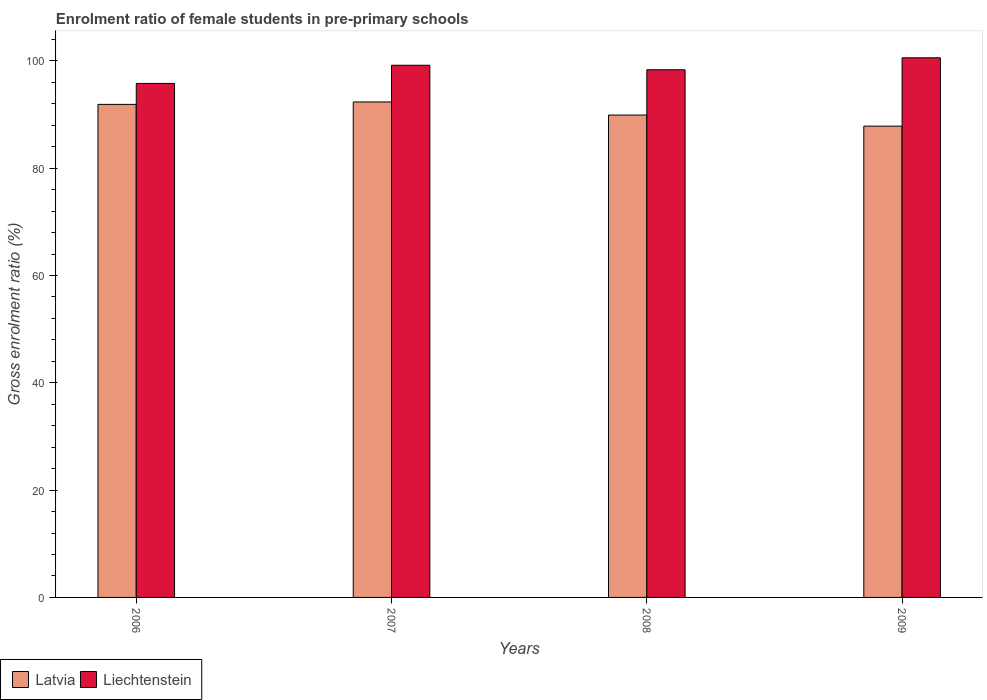How many groups of bars are there?
Ensure brevity in your answer.  4. How many bars are there on the 4th tick from the left?
Offer a terse response. 2. What is the enrolment ratio of female students in pre-primary schools in Latvia in 2008?
Give a very brief answer. 89.9. Across all years, what is the maximum enrolment ratio of female students in pre-primary schools in Liechtenstein?
Your response must be concise. 100.57. Across all years, what is the minimum enrolment ratio of female students in pre-primary schools in Latvia?
Keep it short and to the point. 87.83. In which year was the enrolment ratio of female students in pre-primary schools in Liechtenstein maximum?
Give a very brief answer. 2009. In which year was the enrolment ratio of female students in pre-primary schools in Liechtenstein minimum?
Offer a very short reply. 2006. What is the total enrolment ratio of female students in pre-primary schools in Latvia in the graph?
Your response must be concise. 361.96. What is the difference between the enrolment ratio of female students in pre-primary schools in Liechtenstein in 2007 and that in 2009?
Provide a succinct answer. -1.39. What is the difference between the enrolment ratio of female students in pre-primary schools in Latvia in 2008 and the enrolment ratio of female students in pre-primary schools in Liechtenstein in 2007?
Offer a terse response. -9.28. What is the average enrolment ratio of female students in pre-primary schools in Liechtenstein per year?
Ensure brevity in your answer.  98.47. In the year 2009, what is the difference between the enrolment ratio of female students in pre-primary schools in Latvia and enrolment ratio of female students in pre-primary schools in Liechtenstein?
Make the answer very short. -12.74. What is the ratio of the enrolment ratio of female students in pre-primary schools in Latvia in 2006 to that in 2008?
Your answer should be compact. 1.02. What is the difference between the highest and the second highest enrolment ratio of female students in pre-primary schools in Liechtenstein?
Provide a succinct answer. 1.39. What is the difference between the highest and the lowest enrolment ratio of female students in pre-primary schools in Liechtenstein?
Your response must be concise. 4.78. What does the 2nd bar from the left in 2009 represents?
Provide a succinct answer. Liechtenstein. What does the 1st bar from the right in 2009 represents?
Ensure brevity in your answer.  Liechtenstein. How many years are there in the graph?
Ensure brevity in your answer.  4. What is the difference between two consecutive major ticks on the Y-axis?
Provide a short and direct response. 20. Does the graph contain any zero values?
Keep it short and to the point. No. Does the graph contain grids?
Offer a very short reply. No. How many legend labels are there?
Keep it short and to the point. 2. What is the title of the graph?
Make the answer very short. Enrolment ratio of female students in pre-primary schools. Does "Macedonia" appear as one of the legend labels in the graph?
Provide a short and direct response. No. What is the label or title of the Y-axis?
Ensure brevity in your answer.  Gross enrolment ratio (%). What is the Gross enrolment ratio (%) in Latvia in 2006?
Provide a short and direct response. 91.89. What is the Gross enrolment ratio (%) of Liechtenstein in 2006?
Provide a short and direct response. 95.79. What is the Gross enrolment ratio (%) of Latvia in 2007?
Your answer should be very brief. 92.34. What is the Gross enrolment ratio (%) in Liechtenstein in 2007?
Offer a very short reply. 99.18. What is the Gross enrolment ratio (%) of Latvia in 2008?
Offer a terse response. 89.9. What is the Gross enrolment ratio (%) in Liechtenstein in 2008?
Give a very brief answer. 98.34. What is the Gross enrolment ratio (%) of Latvia in 2009?
Give a very brief answer. 87.83. What is the Gross enrolment ratio (%) in Liechtenstein in 2009?
Make the answer very short. 100.57. Across all years, what is the maximum Gross enrolment ratio (%) in Latvia?
Provide a succinct answer. 92.34. Across all years, what is the maximum Gross enrolment ratio (%) in Liechtenstein?
Give a very brief answer. 100.57. Across all years, what is the minimum Gross enrolment ratio (%) in Latvia?
Your answer should be very brief. 87.83. Across all years, what is the minimum Gross enrolment ratio (%) in Liechtenstein?
Offer a terse response. 95.79. What is the total Gross enrolment ratio (%) of Latvia in the graph?
Provide a succinct answer. 361.96. What is the total Gross enrolment ratio (%) of Liechtenstein in the graph?
Offer a terse response. 393.88. What is the difference between the Gross enrolment ratio (%) in Latvia in 2006 and that in 2007?
Give a very brief answer. -0.45. What is the difference between the Gross enrolment ratio (%) in Liechtenstein in 2006 and that in 2007?
Your response must be concise. -3.39. What is the difference between the Gross enrolment ratio (%) of Latvia in 2006 and that in 2008?
Give a very brief answer. 1.99. What is the difference between the Gross enrolment ratio (%) in Liechtenstein in 2006 and that in 2008?
Make the answer very short. -2.55. What is the difference between the Gross enrolment ratio (%) in Latvia in 2006 and that in 2009?
Ensure brevity in your answer.  4.06. What is the difference between the Gross enrolment ratio (%) of Liechtenstein in 2006 and that in 2009?
Your answer should be very brief. -4.78. What is the difference between the Gross enrolment ratio (%) of Latvia in 2007 and that in 2008?
Offer a very short reply. 2.44. What is the difference between the Gross enrolment ratio (%) of Liechtenstein in 2007 and that in 2008?
Offer a very short reply. 0.84. What is the difference between the Gross enrolment ratio (%) in Latvia in 2007 and that in 2009?
Make the answer very short. 4.51. What is the difference between the Gross enrolment ratio (%) in Liechtenstein in 2007 and that in 2009?
Give a very brief answer. -1.39. What is the difference between the Gross enrolment ratio (%) of Latvia in 2008 and that in 2009?
Make the answer very short. 2.07. What is the difference between the Gross enrolment ratio (%) in Liechtenstein in 2008 and that in 2009?
Offer a terse response. -2.23. What is the difference between the Gross enrolment ratio (%) of Latvia in 2006 and the Gross enrolment ratio (%) of Liechtenstein in 2007?
Ensure brevity in your answer.  -7.29. What is the difference between the Gross enrolment ratio (%) of Latvia in 2006 and the Gross enrolment ratio (%) of Liechtenstein in 2008?
Your answer should be compact. -6.45. What is the difference between the Gross enrolment ratio (%) of Latvia in 2006 and the Gross enrolment ratio (%) of Liechtenstein in 2009?
Give a very brief answer. -8.68. What is the difference between the Gross enrolment ratio (%) in Latvia in 2007 and the Gross enrolment ratio (%) in Liechtenstein in 2008?
Offer a very short reply. -6. What is the difference between the Gross enrolment ratio (%) in Latvia in 2007 and the Gross enrolment ratio (%) in Liechtenstein in 2009?
Offer a very short reply. -8.23. What is the difference between the Gross enrolment ratio (%) of Latvia in 2008 and the Gross enrolment ratio (%) of Liechtenstein in 2009?
Provide a short and direct response. -10.67. What is the average Gross enrolment ratio (%) of Latvia per year?
Keep it short and to the point. 90.49. What is the average Gross enrolment ratio (%) of Liechtenstein per year?
Provide a short and direct response. 98.47. In the year 2006, what is the difference between the Gross enrolment ratio (%) of Latvia and Gross enrolment ratio (%) of Liechtenstein?
Offer a very short reply. -3.9. In the year 2007, what is the difference between the Gross enrolment ratio (%) in Latvia and Gross enrolment ratio (%) in Liechtenstein?
Your response must be concise. -6.84. In the year 2008, what is the difference between the Gross enrolment ratio (%) of Latvia and Gross enrolment ratio (%) of Liechtenstein?
Give a very brief answer. -8.44. In the year 2009, what is the difference between the Gross enrolment ratio (%) of Latvia and Gross enrolment ratio (%) of Liechtenstein?
Your answer should be very brief. -12.74. What is the ratio of the Gross enrolment ratio (%) of Liechtenstein in 2006 to that in 2007?
Offer a very short reply. 0.97. What is the ratio of the Gross enrolment ratio (%) of Latvia in 2006 to that in 2008?
Offer a very short reply. 1.02. What is the ratio of the Gross enrolment ratio (%) in Liechtenstein in 2006 to that in 2008?
Provide a succinct answer. 0.97. What is the ratio of the Gross enrolment ratio (%) of Latvia in 2006 to that in 2009?
Your answer should be very brief. 1.05. What is the ratio of the Gross enrolment ratio (%) in Liechtenstein in 2006 to that in 2009?
Provide a succinct answer. 0.95. What is the ratio of the Gross enrolment ratio (%) in Latvia in 2007 to that in 2008?
Give a very brief answer. 1.03. What is the ratio of the Gross enrolment ratio (%) in Liechtenstein in 2007 to that in 2008?
Keep it short and to the point. 1.01. What is the ratio of the Gross enrolment ratio (%) in Latvia in 2007 to that in 2009?
Your answer should be very brief. 1.05. What is the ratio of the Gross enrolment ratio (%) in Liechtenstein in 2007 to that in 2009?
Give a very brief answer. 0.99. What is the ratio of the Gross enrolment ratio (%) of Latvia in 2008 to that in 2009?
Your answer should be compact. 1.02. What is the ratio of the Gross enrolment ratio (%) of Liechtenstein in 2008 to that in 2009?
Provide a short and direct response. 0.98. What is the difference between the highest and the second highest Gross enrolment ratio (%) in Latvia?
Ensure brevity in your answer.  0.45. What is the difference between the highest and the second highest Gross enrolment ratio (%) of Liechtenstein?
Provide a succinct answer. 1.39. What is the difference between the highest and the lowest Gross enrolment ratio (%) in Latvia?
Give a very brief answer. 4.51. What is the difference between the highest and the lowest Gross enrolment ratio (%) in Liechtenstein?
Give a very brief answer. 4.78. 